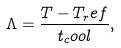Convert formula to latex. <formula><loc_0><loc_0><loc_500><loc_500>\Lambda = \frac { T - T _ { r } e f } { t _ { c } o o l } ,</formula> 